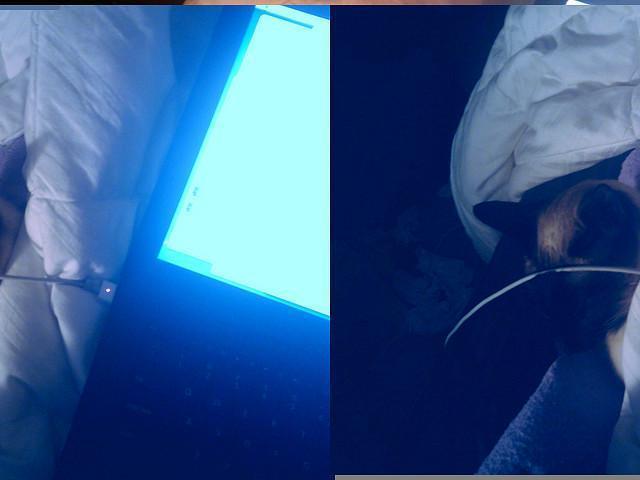How many people are wearing a white shirt?
Give a very brief answer. 0. 